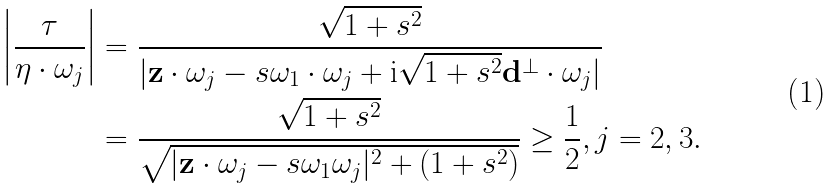Convert formula to latex. <formula><loc_0><loc_0><loc_500><loc_500>\left | \frac { \tau } { \eta \cdot \omega _ { j } } \right | & = \frac { \sqrt { 1 + s ^ { 2 } } } { | \mathbf z \cdot \omega _ { j } - s \omega _ { 1 } \cdot \omega _ { j } + \mathrm i \sqrt { 1 + s ^ { 2 } } \mathbf d ^ { \perp } \cdot \omega _ { j } | } \\ & = \frac { \sqrt { 1 + s ^ { 2 } } } { \sqrt { | \mathbf z \cdot \omega _ { j } - s \omega _ { 1 } \omega _ { j } | ^ { 2 } + ( 1 + s ^ { 2 } ) } } \geq \frac { 1 } { 2 } , j = 2 , 3 .</formula> 